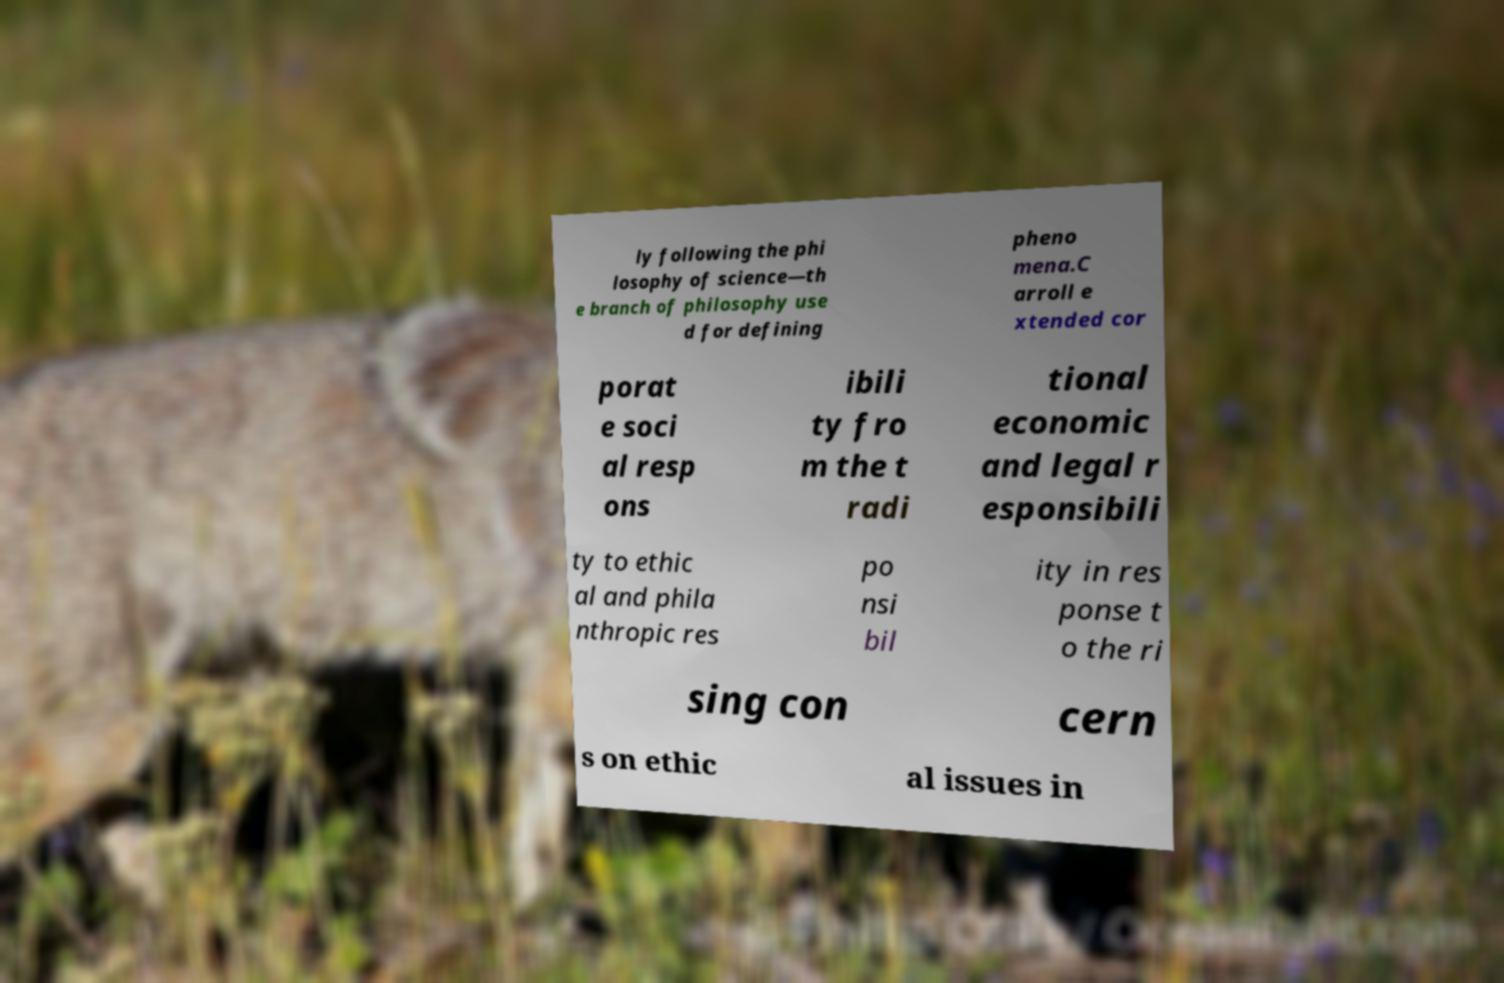Please read and relay the text visible in this image. What does it say? ly following the phi losophy of science—th e branch of philosophy use d for defining pheno mena.C arroll e xtended cor porat e soci al resp ons ibili ty fro m the t radi tional economic and legal r esponsibili ty to ethic al and phila nthropic res po nsi bil ity in res ponse t o the ri sing con cern s on ethic al issues in 